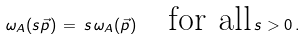Convert formula to latex. <formula><loc_0><loc_0><loc_500><loc_500>\omega _ { A } ( s \vec { p } ) \, = \, s \, \omega _ { A } ( \vec { p } ) \quad \text {for all} \, s > 0 \, .</formula> 